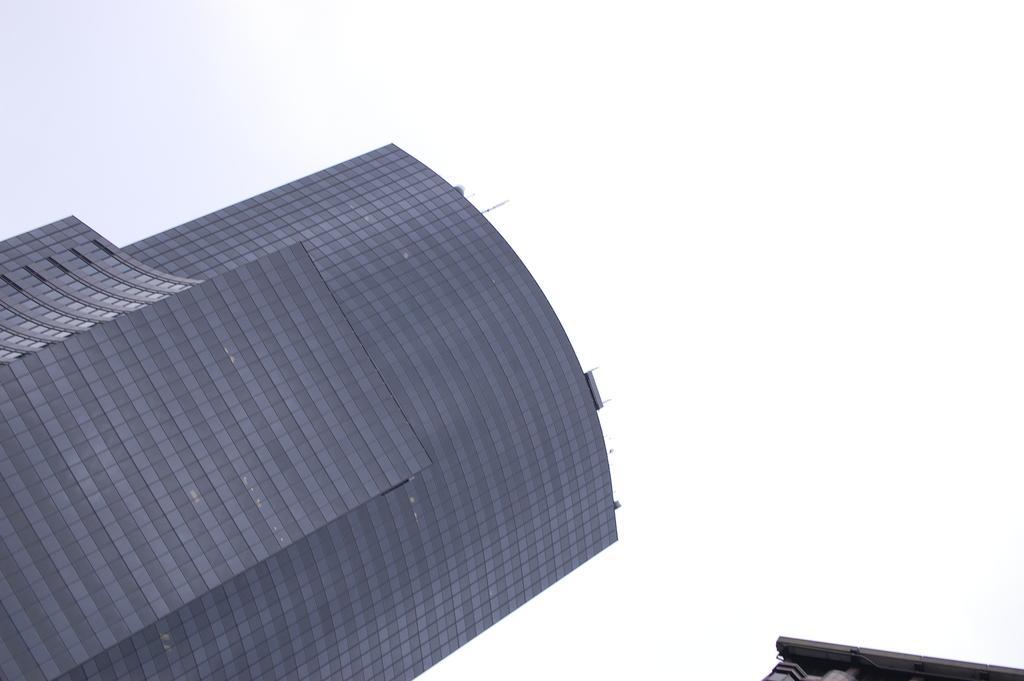Can you describe this image briefly? We can see building and sky. 